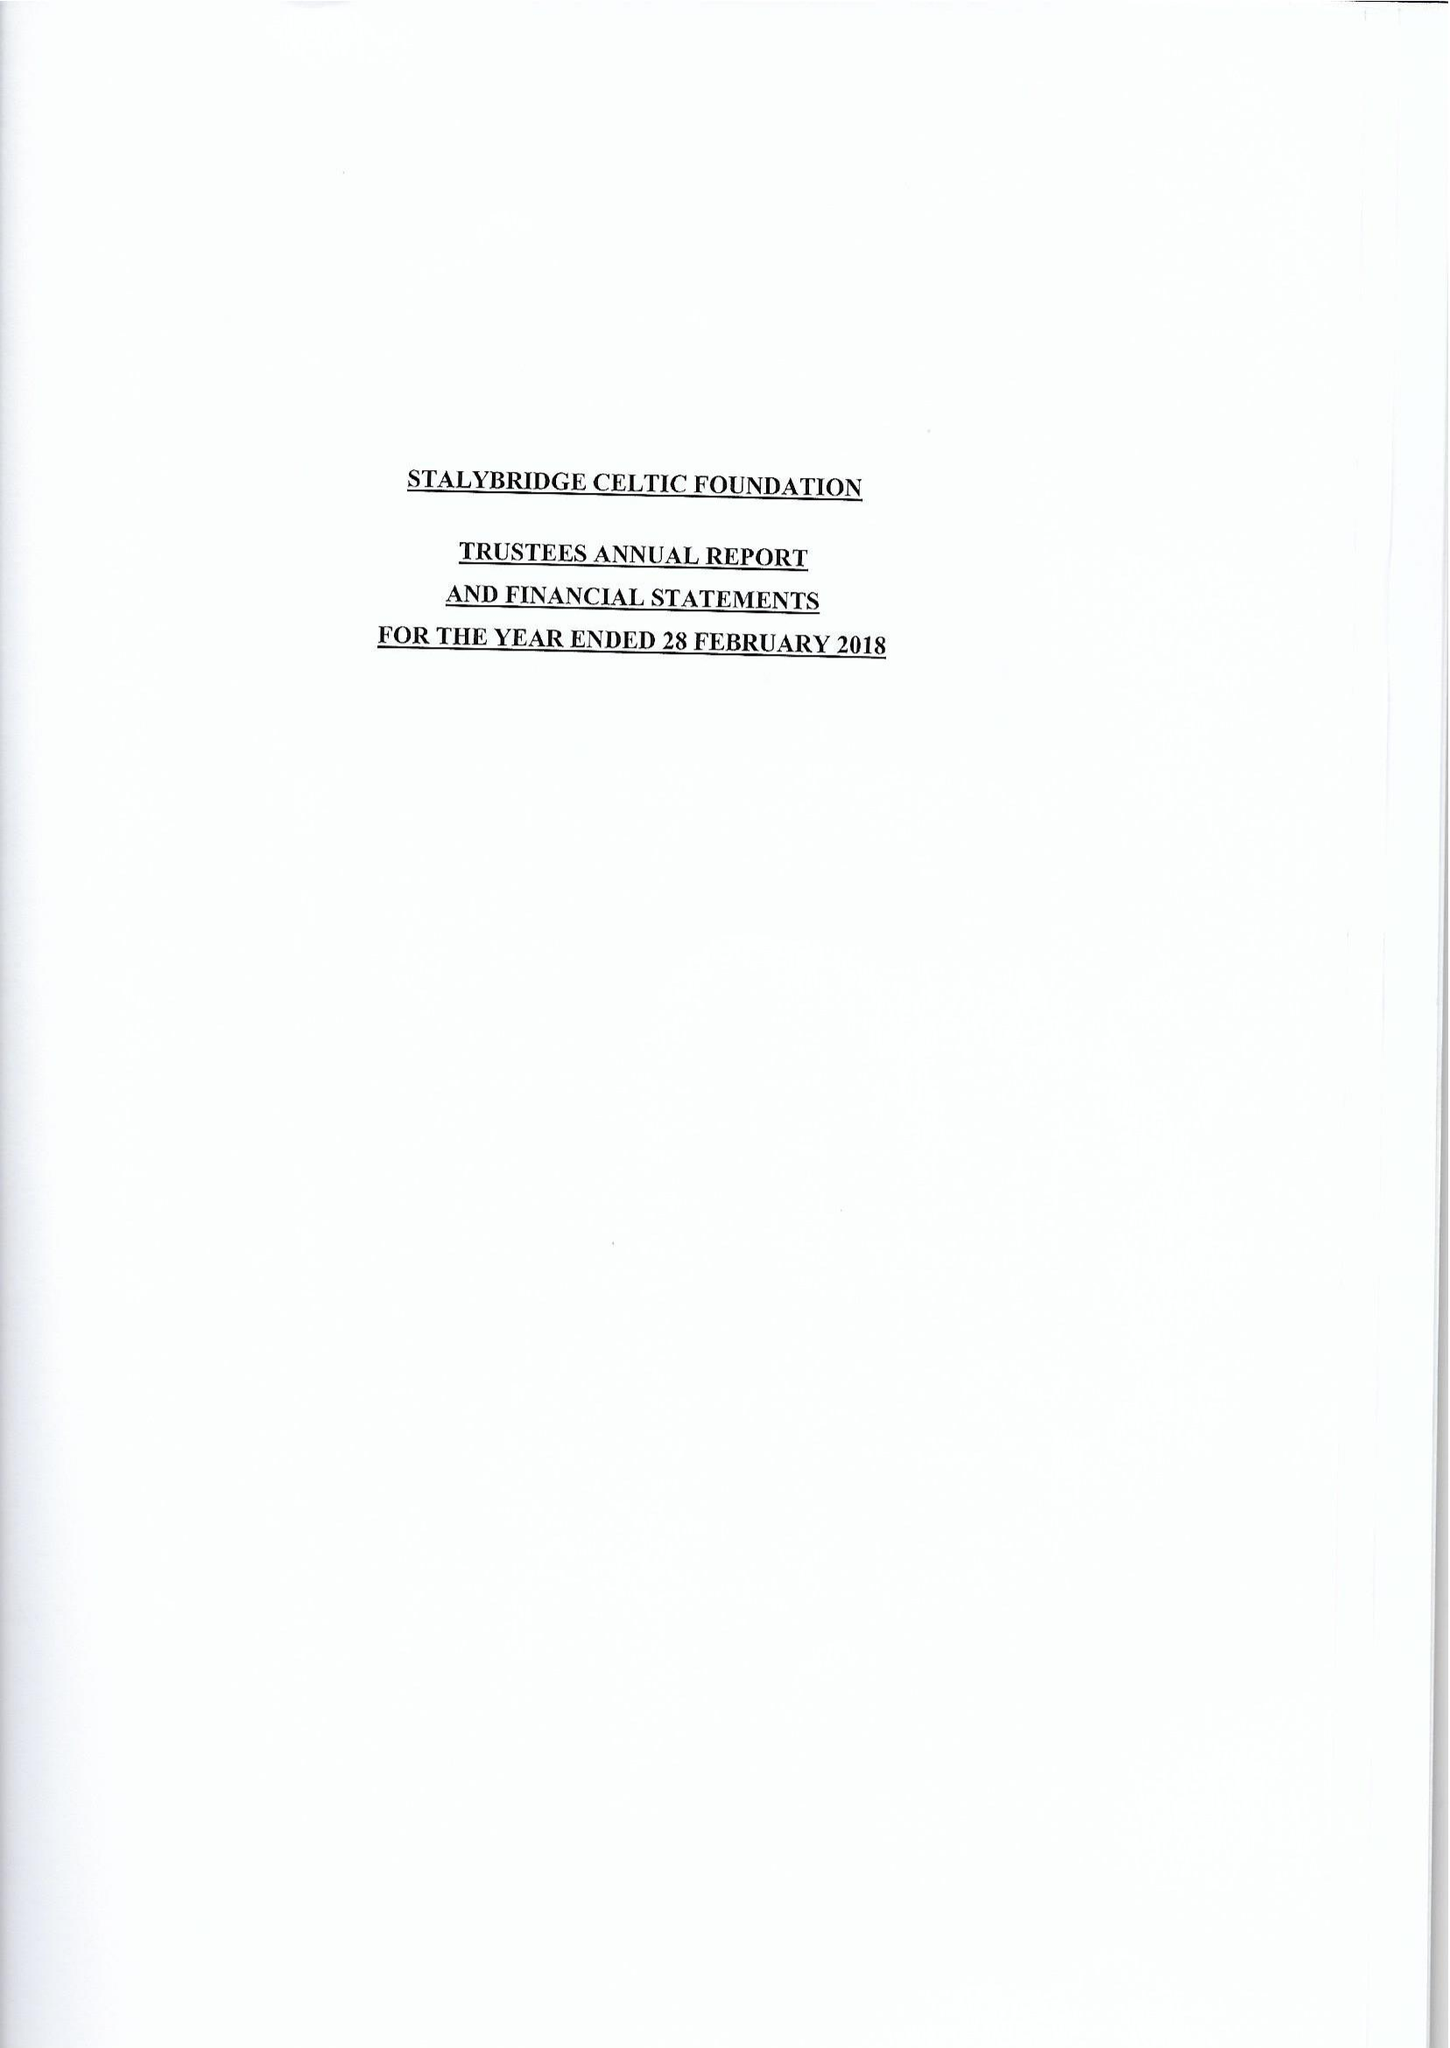What is the value for the address__postcode?
Answer the question using a single word or phrase. SK15 2RT 